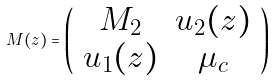Convert formula to latex. <formula><loc_0><loc_0><loc_500><loc_500>M ( z ) = \left ( \begin{array} { c c } M _ { 2 } & u _ { 2 } ( z ) \\ u _ { 1 } ( z ) & \mu _ { c } \end{array} \right )</formula> 